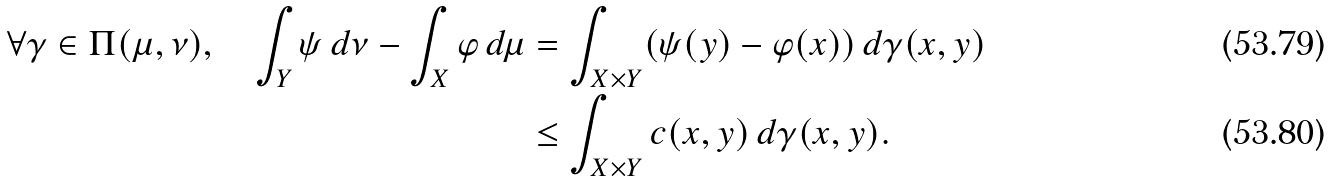<formula> <loc_0><loc_0><loc_500><loc_500>\forall \gamma \in \Pi ( \mu , \nu ) , \quad \int _ { Y } \psi \, d \nu - \int _ { X } \varphi \, d \mu & = \int _ { X \times Y } ( \psi ( y ) - \varphi ( x ) ) \, d \gamma ( x , y ) \\ & \leq \int _ { X \times Y } c ( x , y ) \, d \gamma ( x , y ) .</formula> 